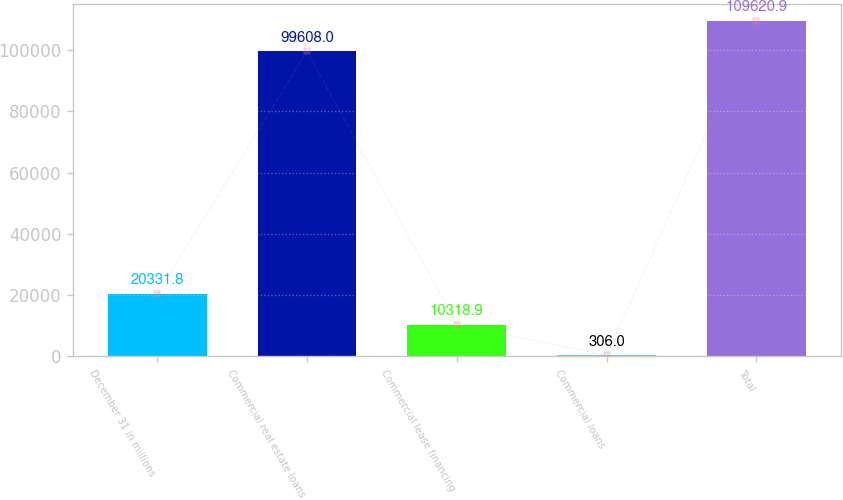Convert chart. <chart><loc_0><loc_0><loc_500><loc_500><bar_chart><fcel>December 31 in millions<fcel>Commercial real estate loans<fcel>Commercial lease financing<fcel>Commercial loans<fcel>Total<nl><fcel>20331.8<fcel>99608<fcel>10318.9<fcel>306<fcel>109621<nl></chart> 